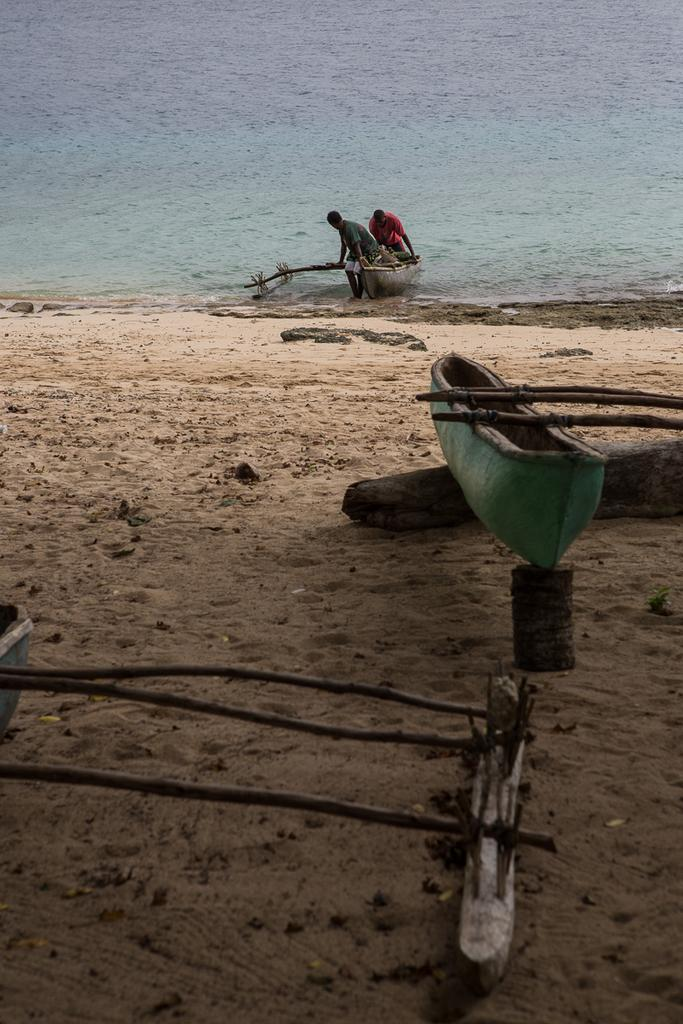What is the main subject of the image? The main subject of the image is a boat. What objects are visible in the image? There are wooden sticks and sand visible in the image. What can be seen in the background of the image? In the background, there is another boat, people, more wooden sticks, and water. What type of riddle is being solved by the people in the background of the image? There is no indication in the image that the people in the background are solving a riddle. 